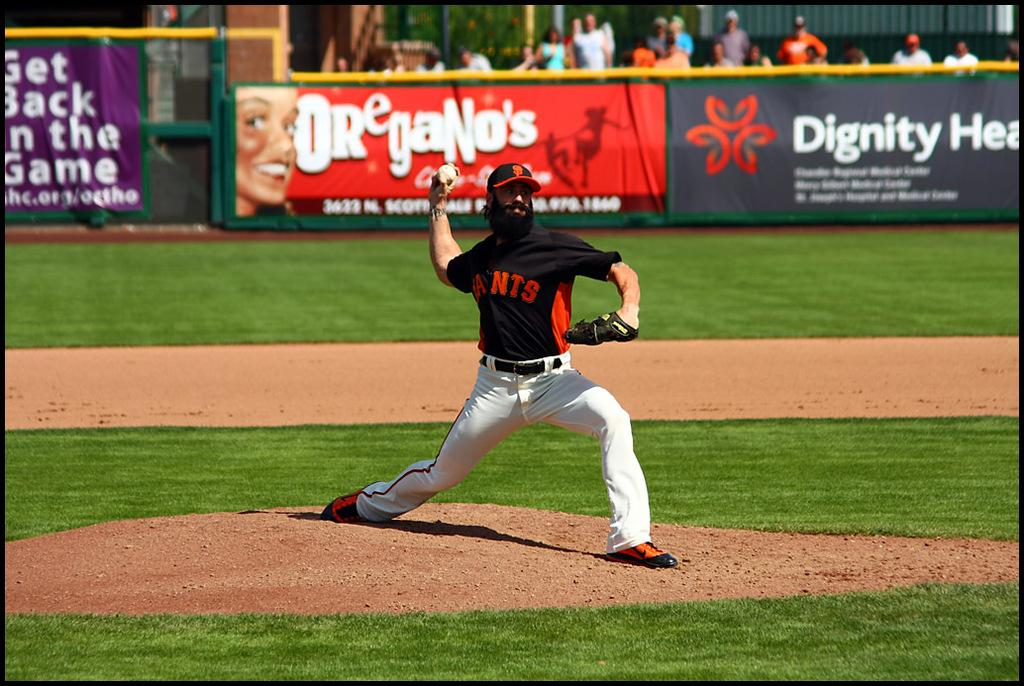<image>
Render a clear and concise summary of the photo. A pitcher from the Giants is throwing the ball. 